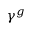Convert formula to latex. <formula><loc_0><loc_0><loc_500><loc_500>\gamma ^ { g }</formula> 